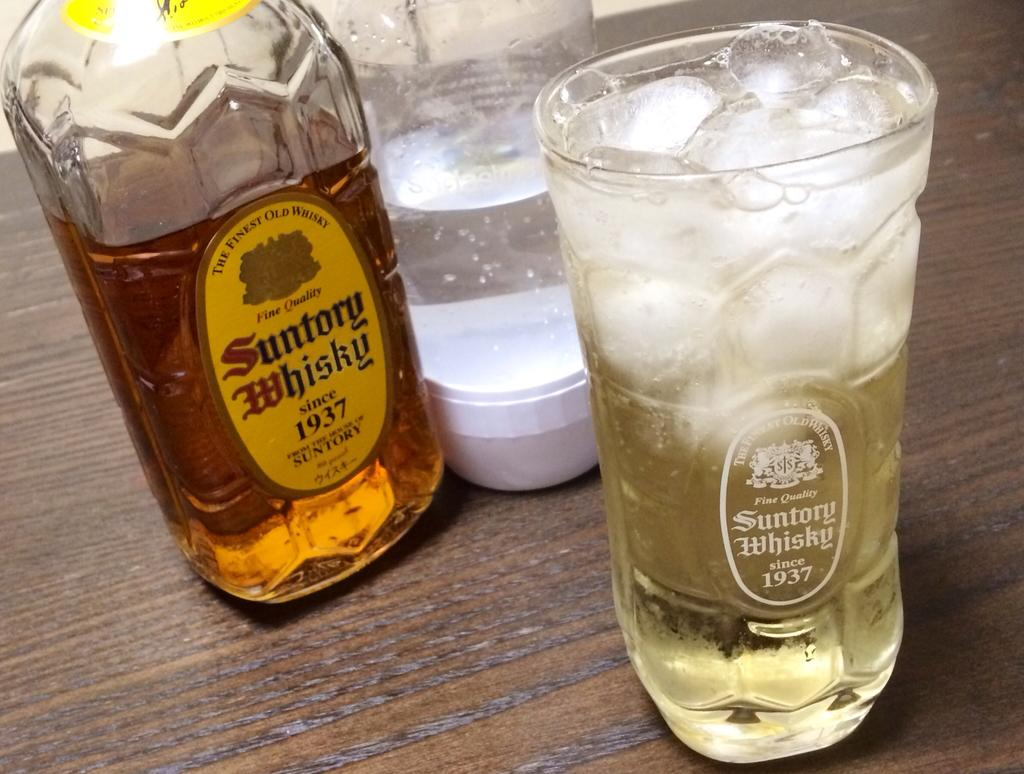<image>
Present a compact description of the photo's key features. Glass and bottle of Suntory Whisky poured over cold ice on a table. 